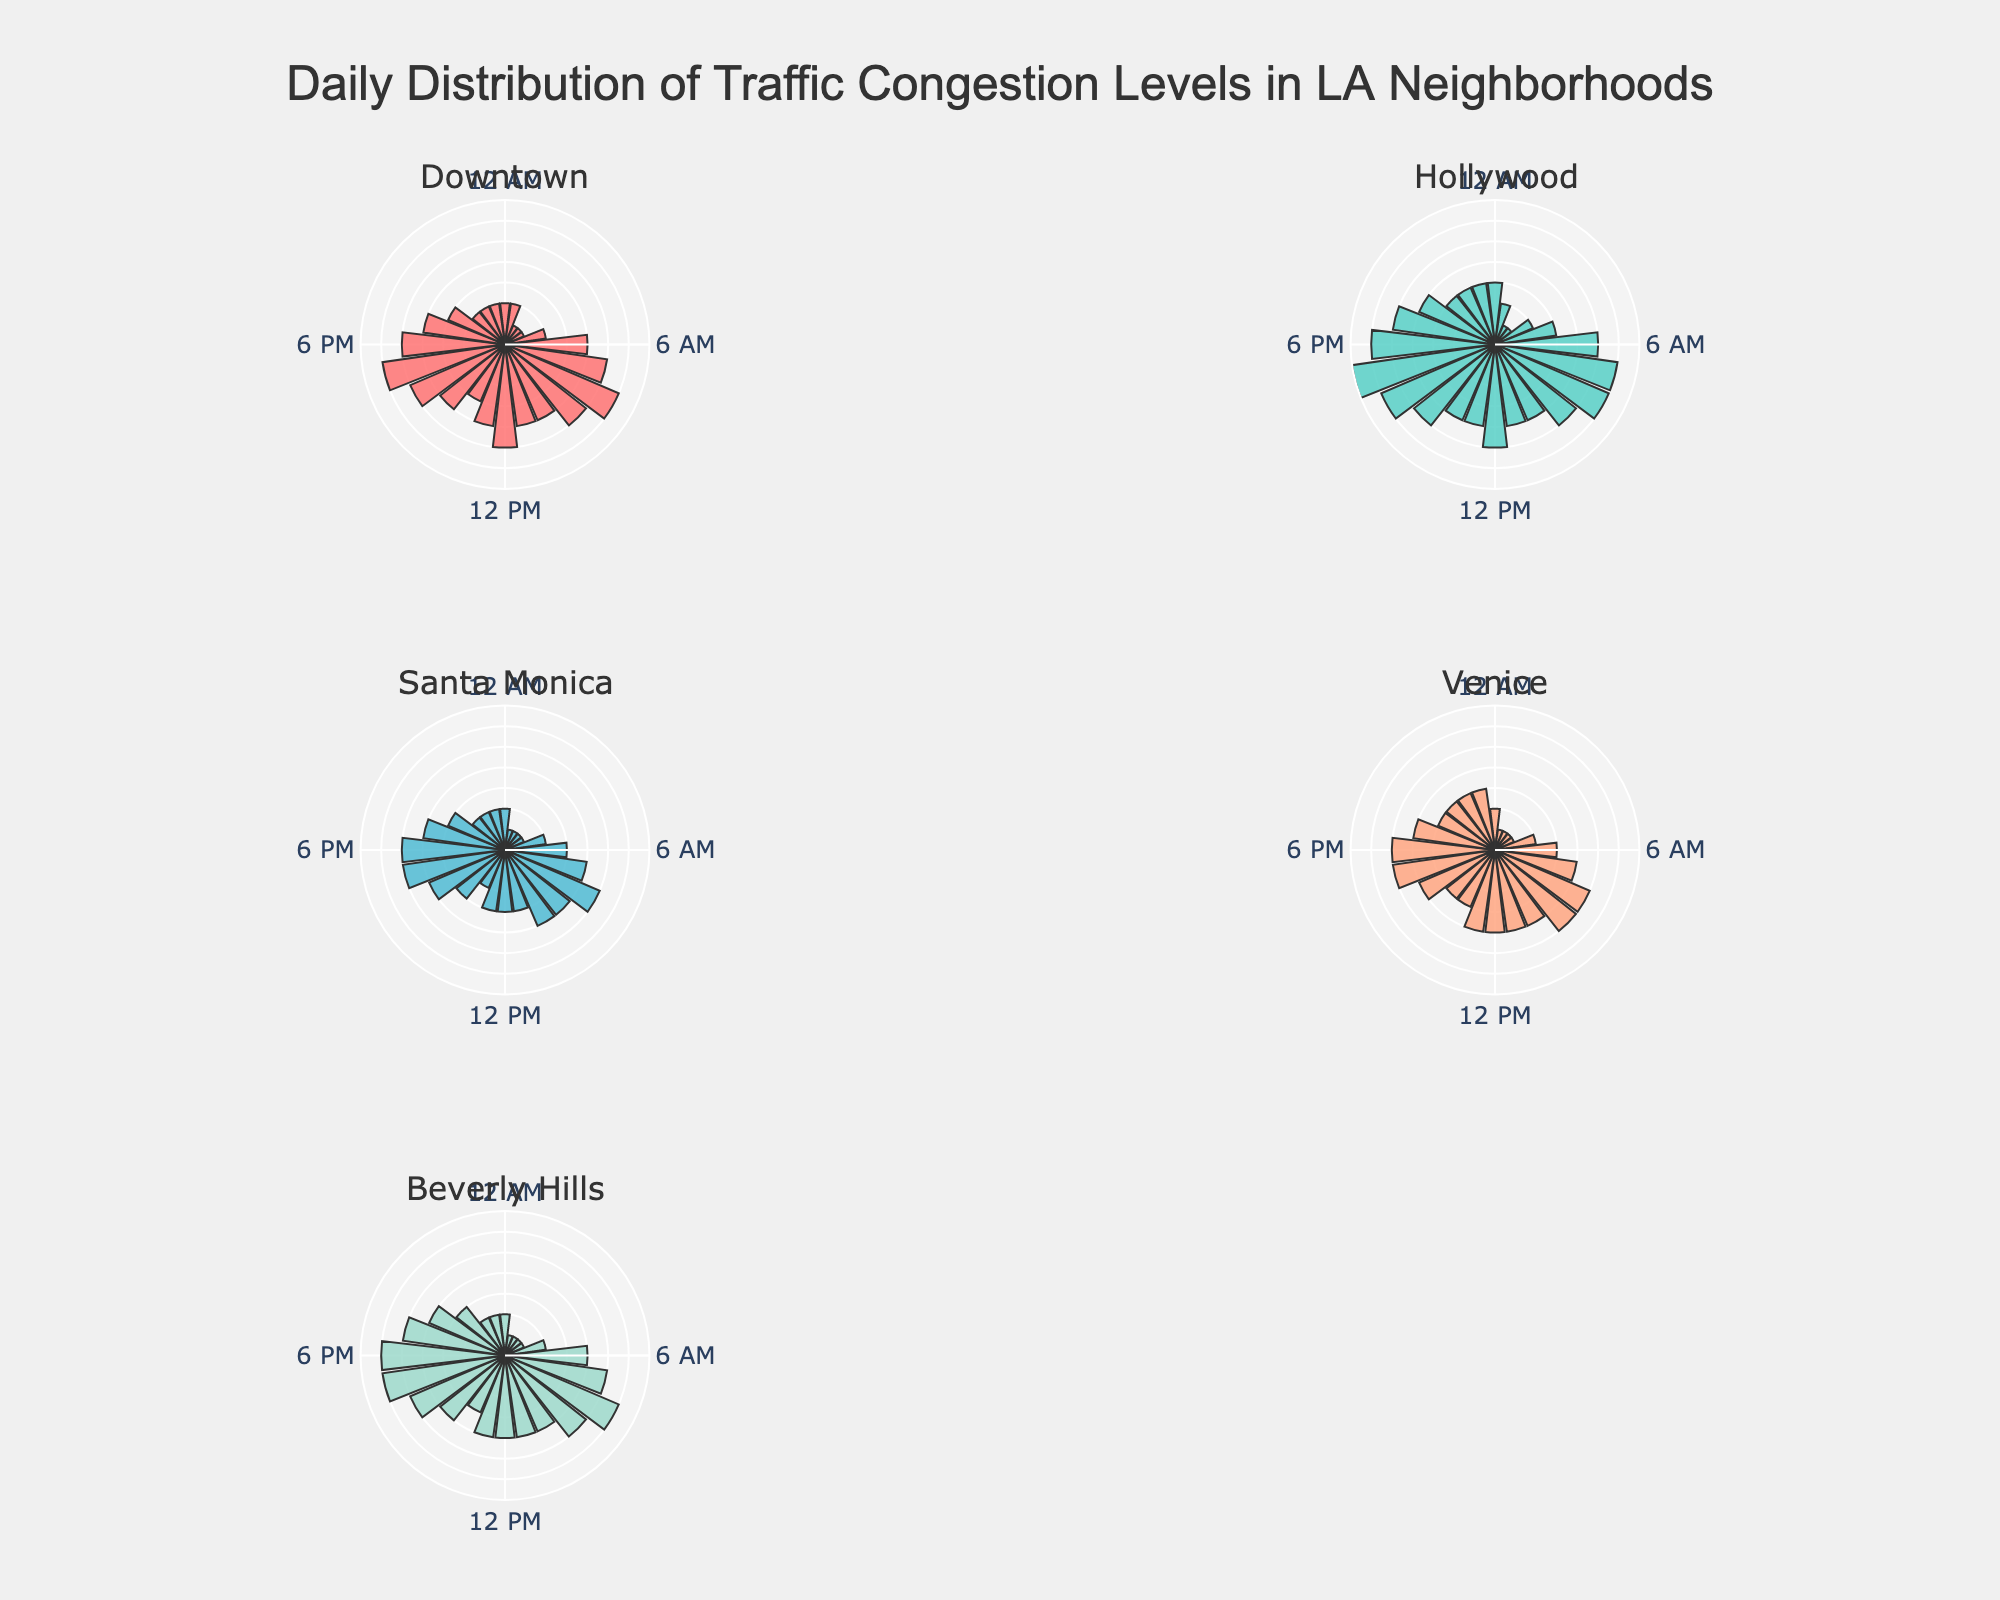What are the hours with the highest traffic congestion level in Downtown? By looking at the rose chart for Downtown, the highest traffic congestion levels are represented by the longest bars. The bars at 8 AM and 5 PM are the longest, indicating the highest traffic congestion levels.
Answer: 8 AM and 5 PM Which neighborhood shows the highest traffic congestion level at 9 AM? Comparing the rose charts for all neighborhoods, the bars at 9 AM are longest in Downtown and Hollywood. Both have congestion levels of 5.
Answer: Downtown and Hollywood What's the average traffic congestion level in Venice around 12 PM? In Venice, the traffic congestion levels for 11 AM, 12 PM, and 1 PM are all 4. Adding them up yields 4 + 4 + 4 = 12, and dividing by 3 gives an average of 4.
Answer: 4 Is there any neighborhood with less than 3 traffic congestion levels throughout a 24-hour period? By observing the rose charts, Santa Monica and Venice have periods where the congestion levels are less than 3. However, none have congestion levels less than 3 for every hour.
Answer: No Which neighborhood has the sharpest rise in traffic congestion in the morning hours? By reviewing the rose charts, Hollywood shows a rapid increase in congestion levels from 5 AM (level 4) to 8 AM (level 6), indicating the sharpest rise.
Answer: Hollywood At what time is the traffic congestion level the lowest in Beverly Hills, and what is the level? In Beverly Hills, the lowest congestion levels are at 2 AM, 3 AM, and 4 AM, with a level of 1.
Answer: 2 AM, 3 AM, and 4 AM (level 1) Compare the traffic congestion levels at 6 PM for all neighborhoods. Which neighborhood shows the highest level? By looking at the rose charts, the bars at 6 PM are longest in Hollywood with a congestion level of 6.
Answer: Hollywood How does the traffic congestion level at 8 AM compare between Santa Monica and Venice? In Santa Monica, the congestion level at 8 AM is 5, while in Venice, it is also 5.
Answer: Equal (5) What is the pattern of traffic congestion in Downtown from 2 AM to 5 AM? The rose chart for Downtown shows congestion levels are 1 from 2 AM to 4 AM and 2 at 5 AM, indicating low traffic congestion during these hours.
Answer: 1 from 2 AM to 4 AM, 2 at 5 AM Which neighborhood has the most consistent traffic congestion level throughout the day? By examining the rose charts, Venice appears to have consistent traffic congestion levels, mostly staying between 3 and 5 throughout the day.
Answer: Venice 